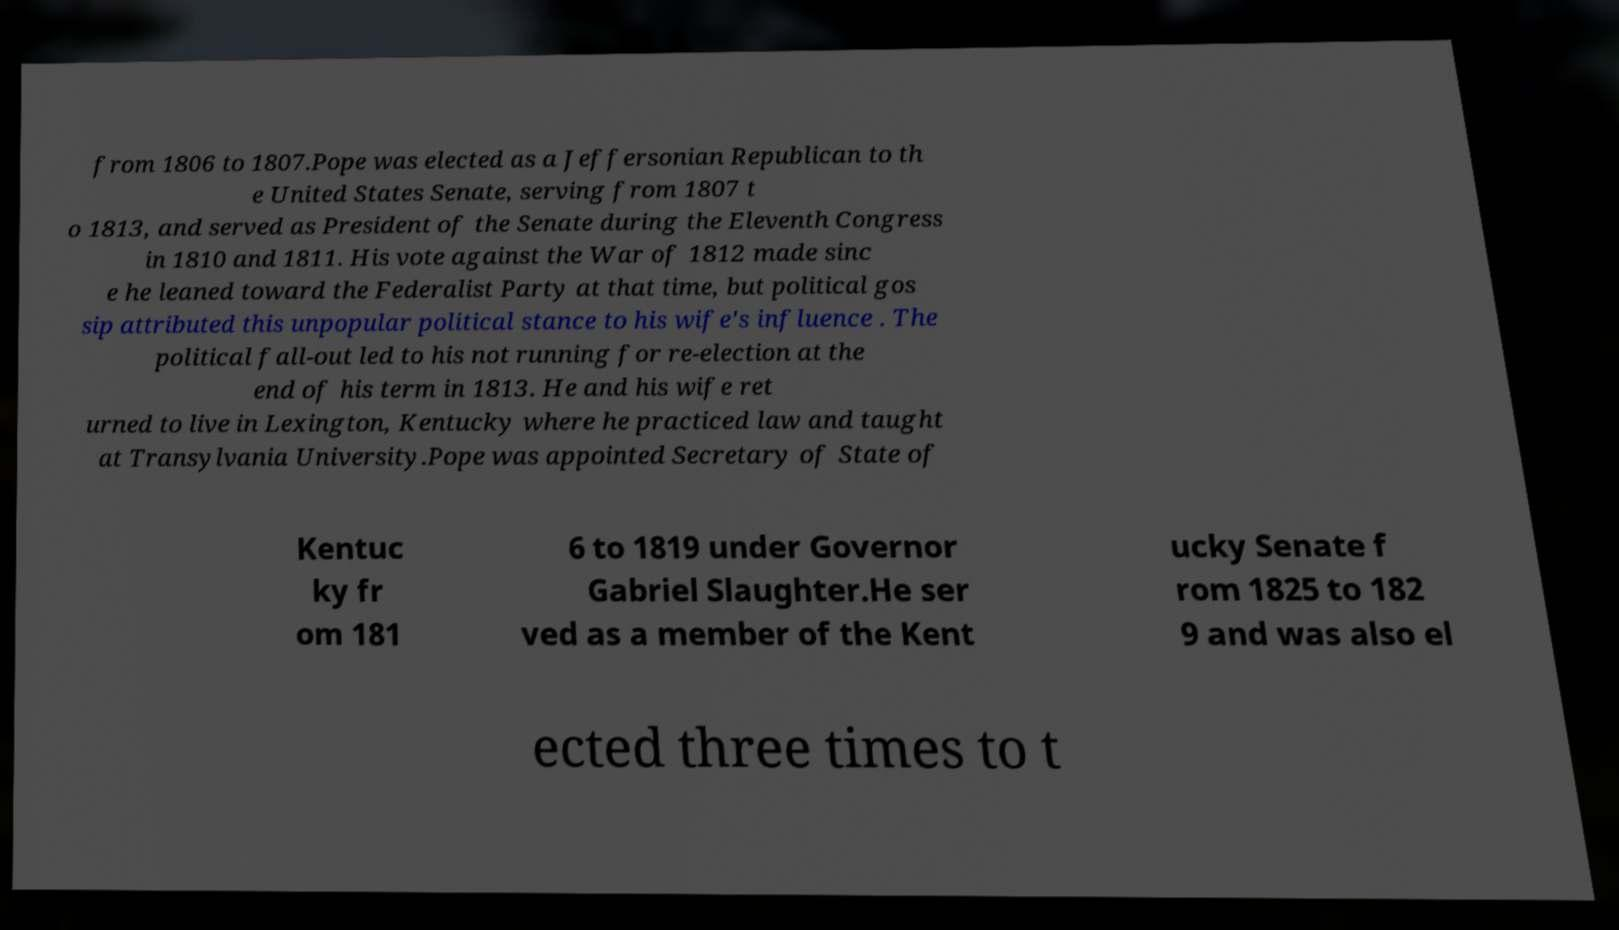Could you extract and type out the text from this image? from 1806 to 1807.Pope was elected as a Jeffersonian Republican to th e United States Senate, serving from 1807 t o 1813, and served as President of the Senate during the Eleventh Congress in 1810 and 1811. His vote against the War of 1812 made sinc e he leaned toward the Federalist Party at that time, but political gos sip attributed this unpopular political stance to his wife's influence . The political fall-out led to his not running for re-election at the end of his term in 1813. He and his wife ret urned to live in Lexington, Kentucky where he practiced law and taught at Transylvania University.Pope was appointed Secretary of State of Kentuc ky fr om 181 6 to 1819 under Governor Gabriel Slaughter.He ser ved as a member of the Kent ucky Senate f rom 1825 to 182 9 and was also el ected three times to t 